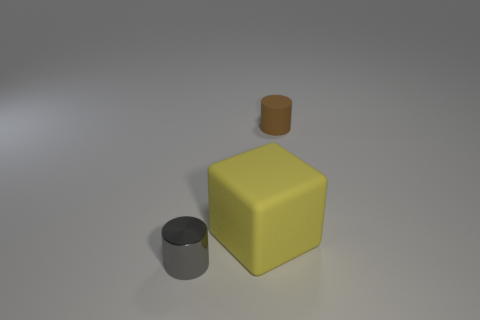Add 3 small red rubber cubes. How many objects exist? 6 Subtract all blocks. How many objects are left? 2 Subtract all matte objects. Subtract all small brown cylinders. How many objects are left? 0 Add 1 yellow things. How many yellow things are left? 2 Add 1 big cyan rubber things. How many big cyan rubber things exist? 1 Subtract 0 cyan blocks. How many objects are left? 3 